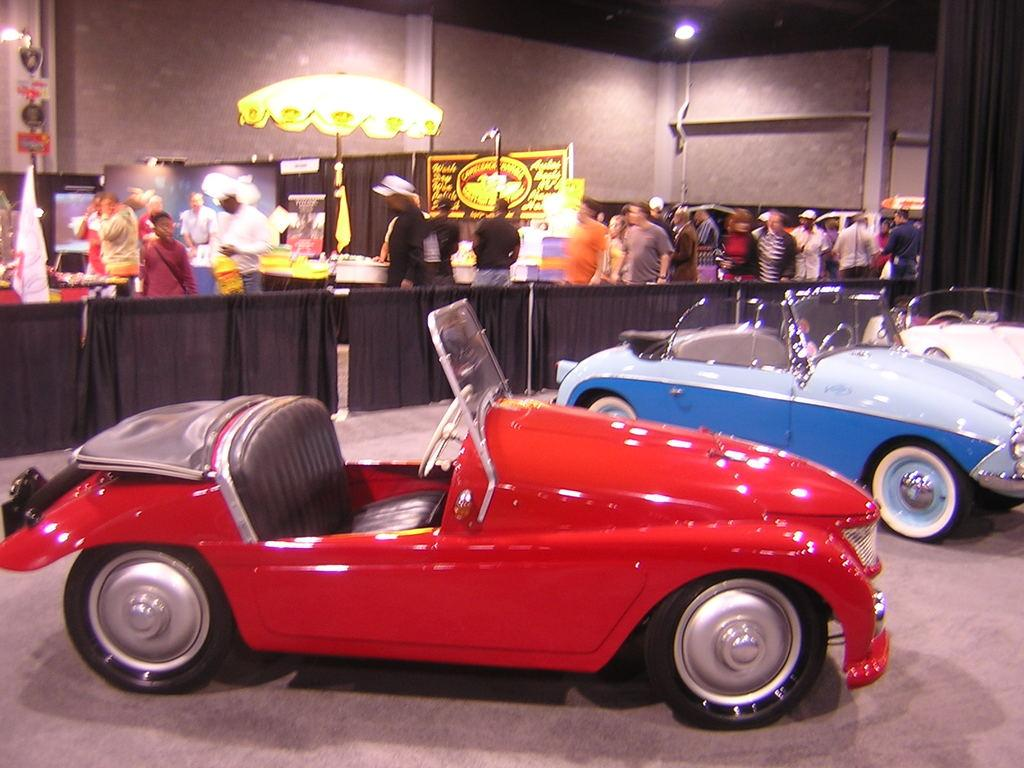What can be seen in the image? There are vehicles, people standing, and a wall in the image. What is visible in the background of the image? In the background of the image, there are curtains, a parasol, boards, and lights. What might be used for shade in the image? The parasol in the background of the image might be used for shade. What type of wood can be seen causing the zephyr in the image? There is no wood or zephyr present in the image. What is the cause of the zephyr in the image? There is no zephyr present in the image, so there is no cause for it. 